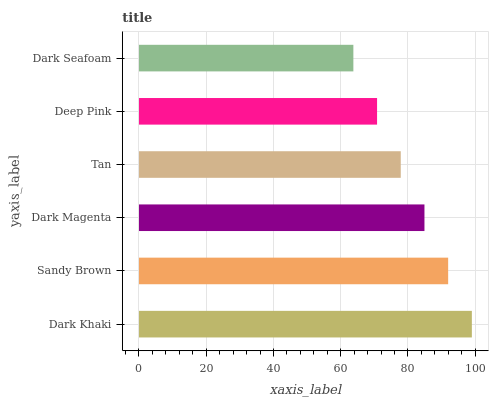Is Dark Seafoam the minimum?
Answer yes or no. Yes. Is Dark Khaki the maximum?
Answer yes or no. Yes. Is Sandy Brown the minimum?
Answer yes or no. No. Is Sandy Brown the maximum?
Answer yes or no. No. Is Dark Khaki greater than Sandy Brown?
Answer yes or no. Yes. Is Sandy Brown less than Dark Khaki?
Answer yes or no. Yes. Is Sandy Brown greater than Dark Khaki?
Answer yes or no. No. Is Dark Khaki less than Sandy Brown?
Answer yes or no. No. Is Dark Magenta the high median?
Answer yes or no. Yes. Is Tan the low median?
Answer yes or no. Yes. Is Sandy Brown the high median?
Answer yes or no. No. Is Dark Seafoam the low median?
Answer yes or no. No. 